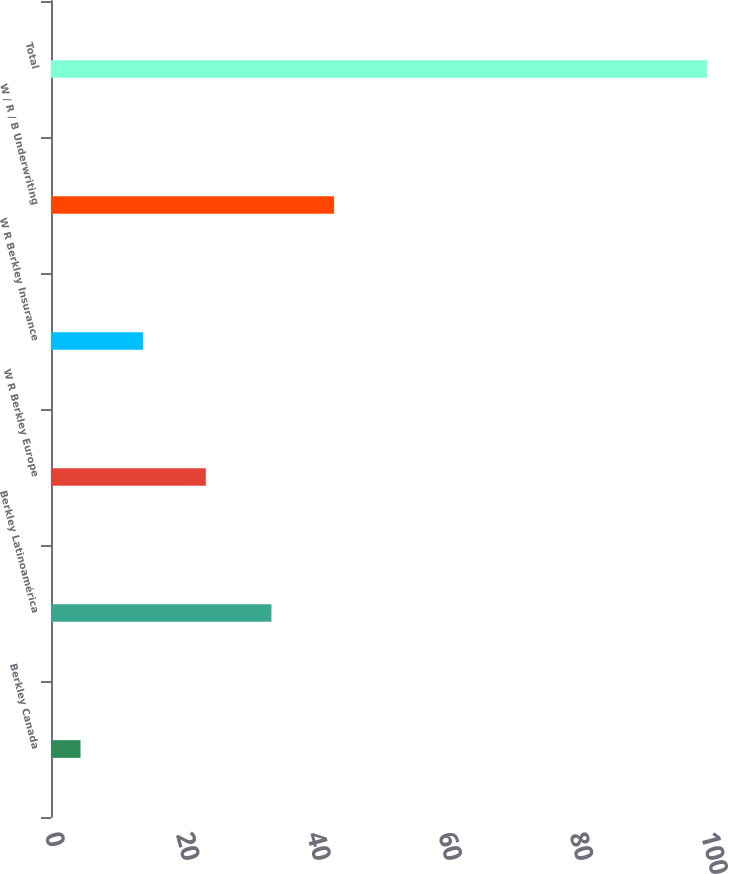Convert chart. <chart><loc_0><loc_0><loc_500><loc_500><bar_chart><fcel>Berkley Canada<fcel>Berkley Latinoamérica<fcel>W R Berkley Europe<fcel>W R Berkley Insurance<fcel>W / R / B Underwriting<fcel>Total<nl><fcel>4.5<fcel>33.6<fcel>23.6<fcel>14.05<fcel>43.15<fcel>100<nl></chart> 